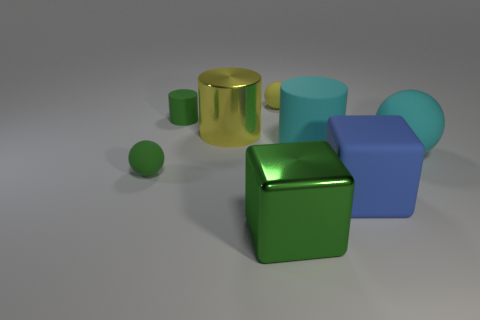Add 1 green blocks. How many objects exist? 9 Subtract all blocks. How many objects are left? 6 Subtract 0 brown cylinders. How many objects are left? 8 Subtract all tiny green matte balls. Subtract all yellow things. How many objects are left? 5 Add 6 large shiny objects. How many large shiny objects are left? 8 Add 3 big yellow metal things. How many big yellow metal things exist? 4 